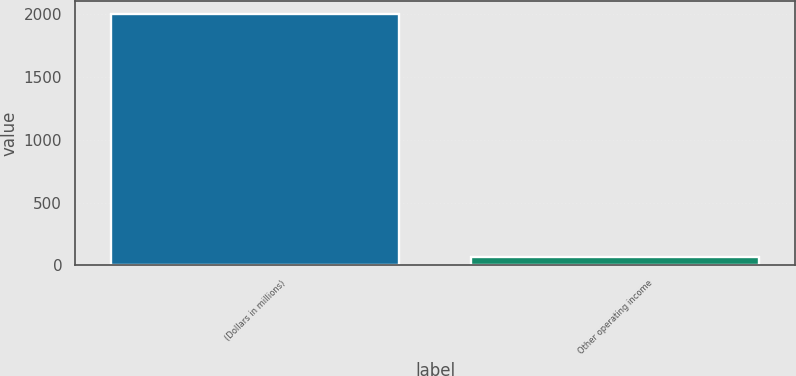Convert chart to OTSL. <chart><loc_0><loc_0><loc_500><loc_500><bar_chart><fcel>(Dollars in millions)<fcel>Other operating income<nl><fcel>2006<fcel>68<nl></chart> 